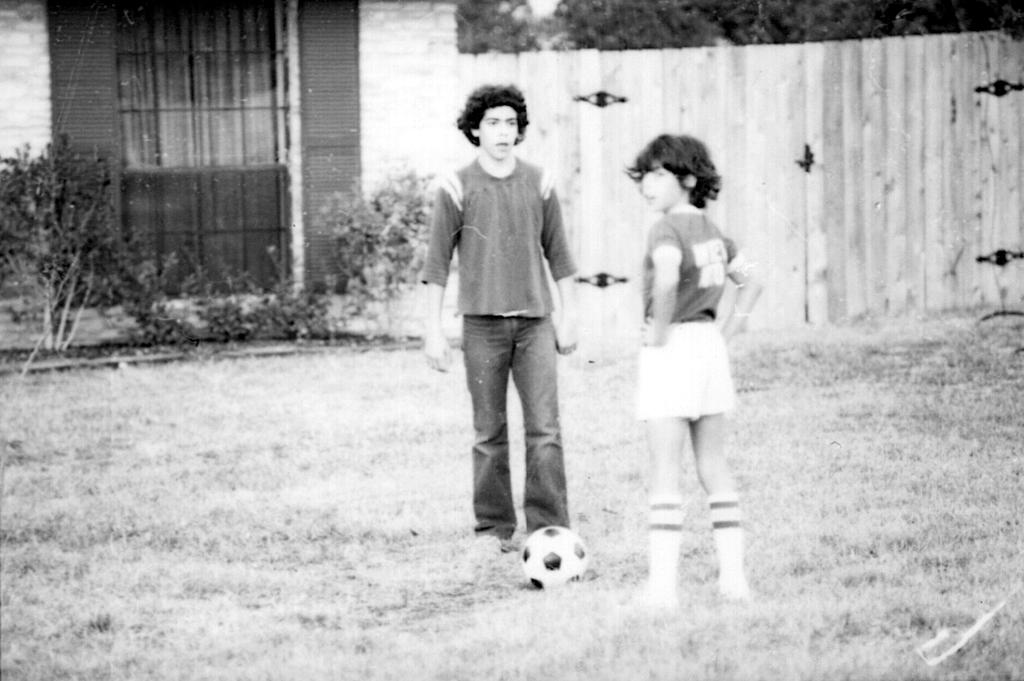What can be seen in the image involving human figures? There are human figures standing in the image. What object is on the ground near the human figures? There is a football on the ground. What type of structure is visible in the image? There is a house in the image. What type of vegetation is present in the image? Plants and trees are present in the image. What is the ground surface made of in the image? Grass is visible on the ground. What type of barrier can be seen in the image? A wooden fence is present in the image. What type of government is depicted in the image? There is no depiction of a government in the image; it features human figures, a football, a house, plants, trees, grass, and a wooden fence. How many eggs are visible in the image? There are no eggs present in the image. 